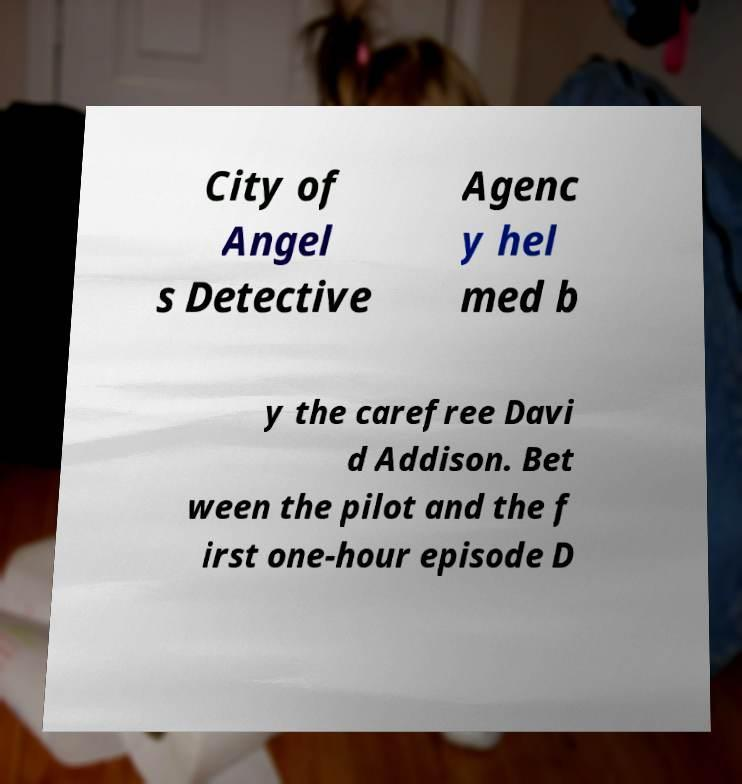For documentation purposes, I need the text within this image transcribed. Could you provide that? City of Angel s Detective Agenc y hel med b y the carefree Davi d Addison. Bet ween the pilot and the f irst one-hour episode D 